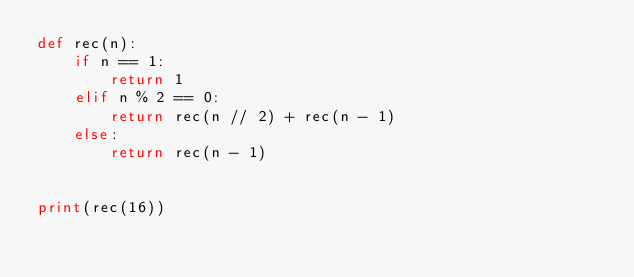Convert code to text. <code><loc_0><loc_0><loc_500><loc_500><_Python_>def rec(n):
    if n == 1:
        return 1
    elif n % 2 == 0:
        return rec(n // 2) + rec(n - 1)
    else:
        return rec(n - 1)


print(rec(16))
</code> 